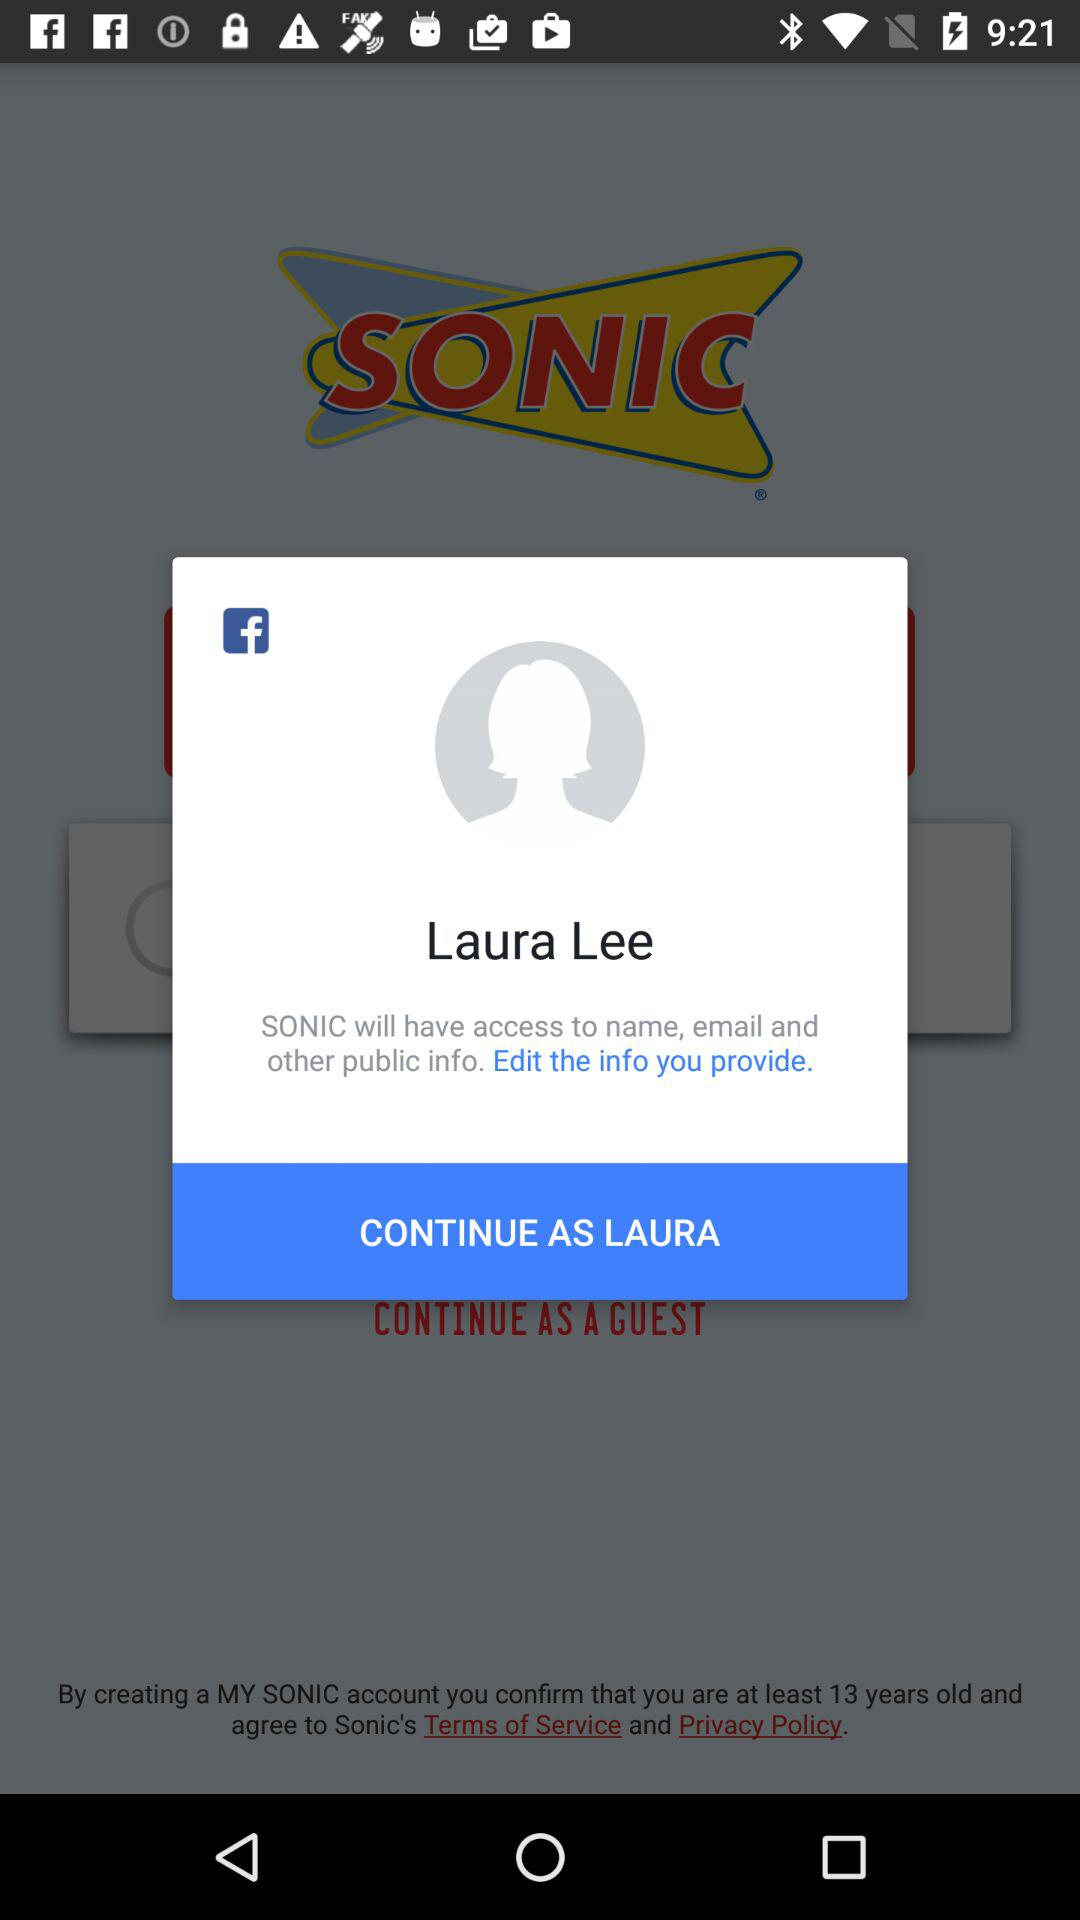What application will have access to names, email and other public information? The application is "SONIC". 